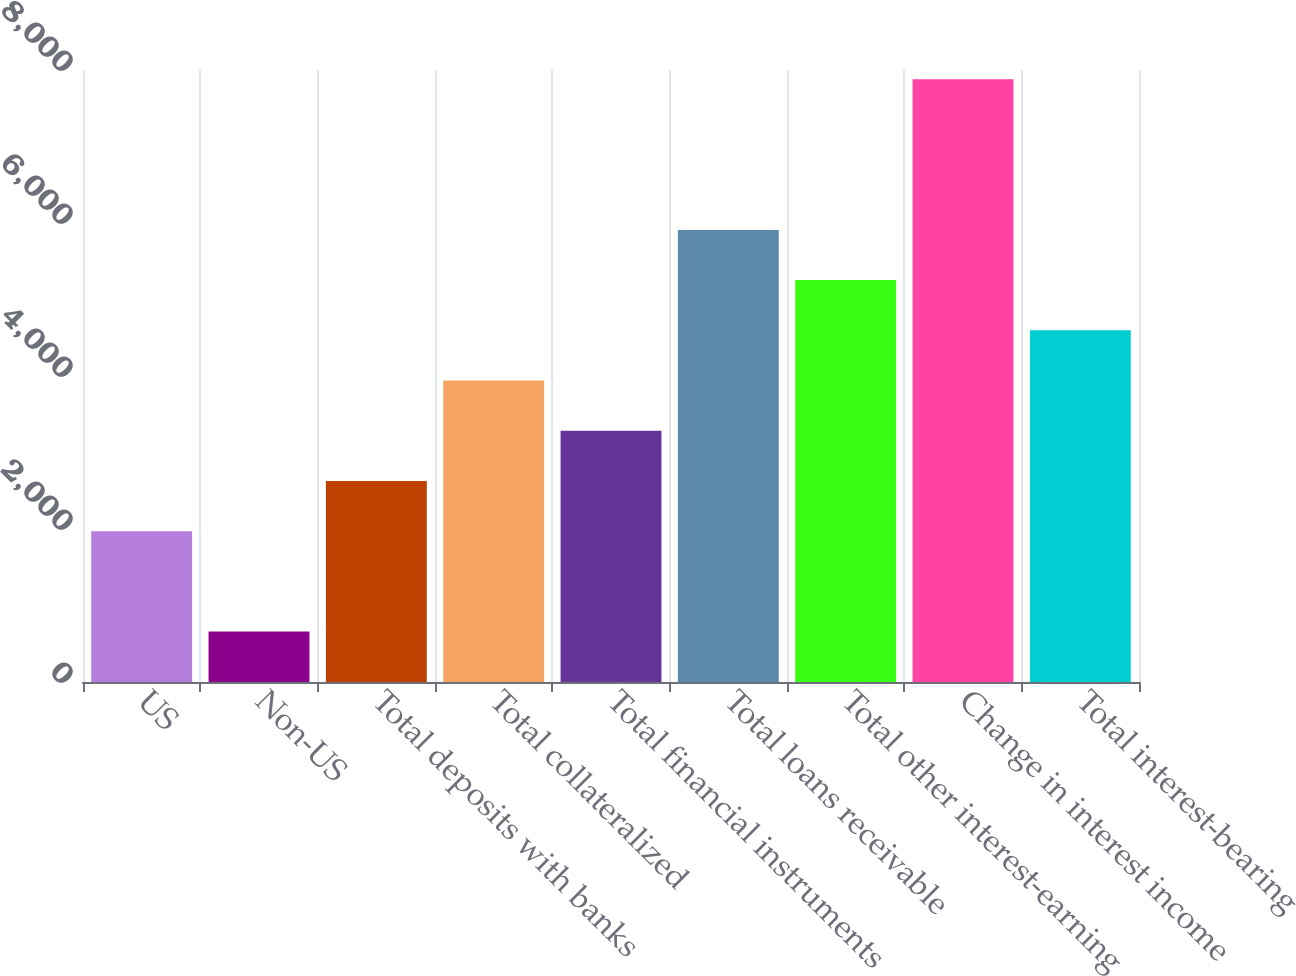<chart> <loc_0><loc_0><loc_500><loc_500><bar_chart><fcel>US<fcel>Non-US<fcel>Total deposits with banks<fcel>Total collateralized<fcel>Total financial instruments<fcel>Total loans receivable<fcel>Total other interest-earning<fcel>Change in interest income<fcel>Total interest-bearing<nl><fcel>1971.9<fcel>659.3<fcel>2628.2<fcel>3940.8<fcel>3284.5<fcel>5909.7<fcel>5253.4<fcel>7878.6<fcel>4597.1<nl></chart> 